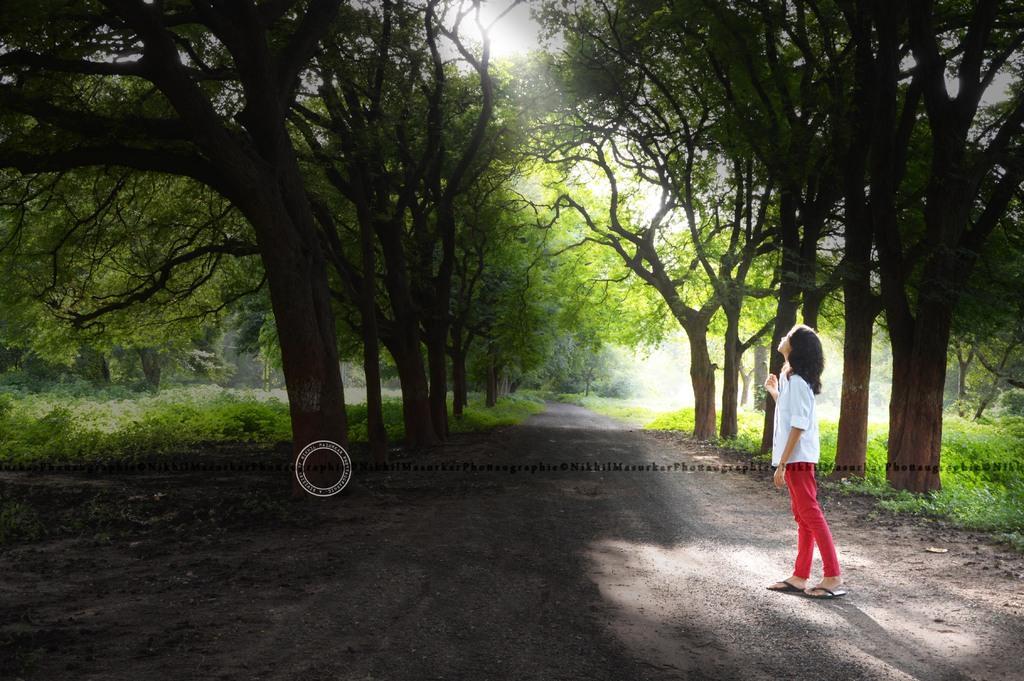Can you describe this image briefly? It is an edited image, there is a girl standing in between the road and on the either side of the road there are plenty of trees and grass. 